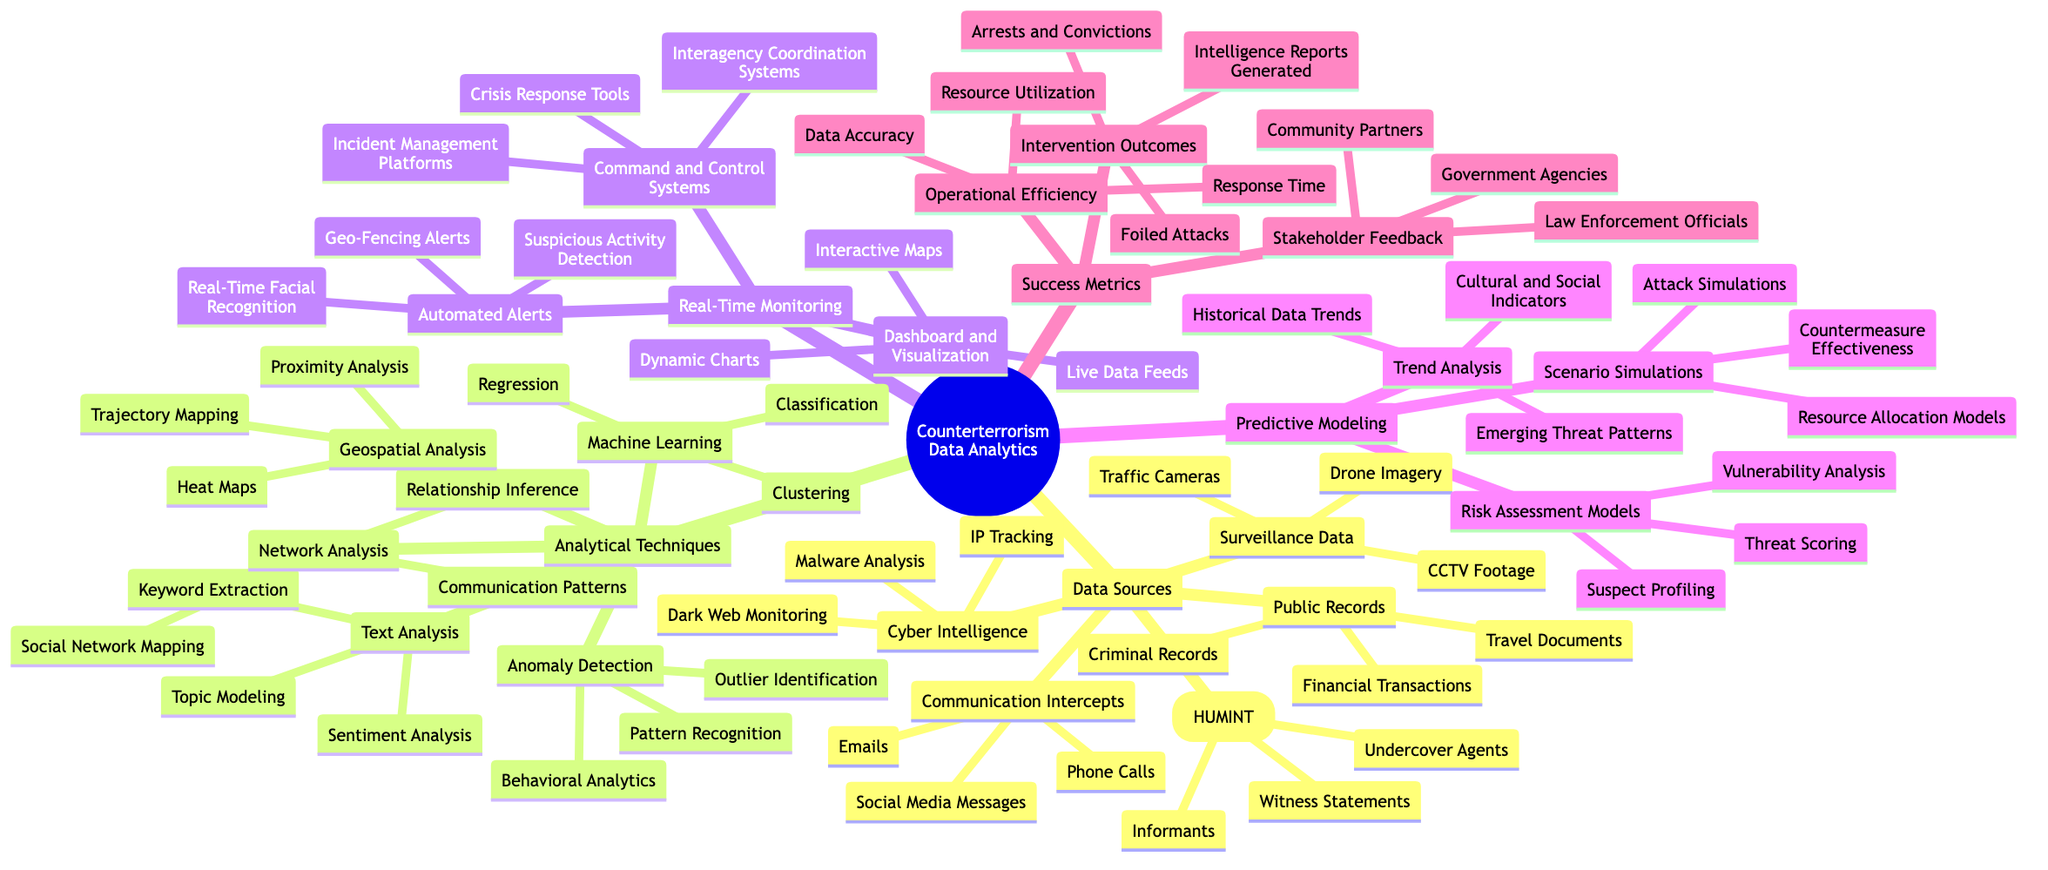what are the three main categories of data sources in this diagram? The diagram lists five main categories under "Data Sources": Surveillance Data, Communication Intercepts, Public Records, Human Intelligence (HUMINT), and Cyber Intelligence. Upon checking, the first three specified are Surveillance Data, Communication Intercepts, and Public Records
Answer: Surveillance Data, Communication Intercepts, Public Records how many types of analytical techniques are there in the diagram? The diagram presents five types of analytical techniques: Text Analysis, Network Analysis, Geospatial Analysis, Anomaly Detection, and Machine Learning. Counting these, we find there are five distinct types
Answer: five which data source includes financial transactions? Under the category "Public Records," one of the specific data sources listed is Financial Transactions. Thus, the data source that includes financial transactions is Public Records
Answer: Public Records what is one example of real-time monitoring listed in the diagram? The Real-Time Monitoring section includes various examples, such as Automated Alerts, which lists specific instances like Suspicious Activity Detection and Geo-Fencing Alerts. The term "Automated Alerts" serves as a direct example in that section
Answer: Automated Alerts how are intervention outcomes measured according to the diagram? In the "Success Metrics" section, the measure of intervention outcomes includes three specific examples: Foiled Attacks, Arrests and Convictions, and Intelligence Reports Generated. Thus, the intervention outcomes are assessed through these three metrics
Answer: Foiled Attacks, Arrests and Convictions, Intelligence Reports Generated which analytical technique would help identify unusual patterns in data? Anomaly Detection is the analytical technique specifically aimed at identifying unusual patterns, as it covers aspects like Pattern Recognition, Behavioral Analytics, and Outlier Identification. Therefore, this technique encompasses all forms of unusual or unexpected data patterns
Answer: Anomaly Detection how many different types of human intelligence (HUMINT) sources are included? The diagram cites three distinct types within the Human Intelligence (HUMINT) category: Informants, Undercover Agents, and Witness Statements. Counting these gives us a total of three different HUMINT sources
Answer: three what function does the dashboard serve in real-time monitoring? The Dashboard and Visualization component in Real-Time Monitoring provides essential functions such as Live Data Feeds, Interactive Maps, and Dynamic Charts, all aimed at visualizing and managing data efficiently. It primarily serves as a tool for visualization in this context
Answer: Dashboard and Visualization what type of analysis includes threat scoring? Threat Scoring is specifically included under Risk Assessment Models, which falls into the category of Predictive Modeling in the diagram. Hence, it is associated with predictive analysis focused on risk
Answer: Predictive Modeling 